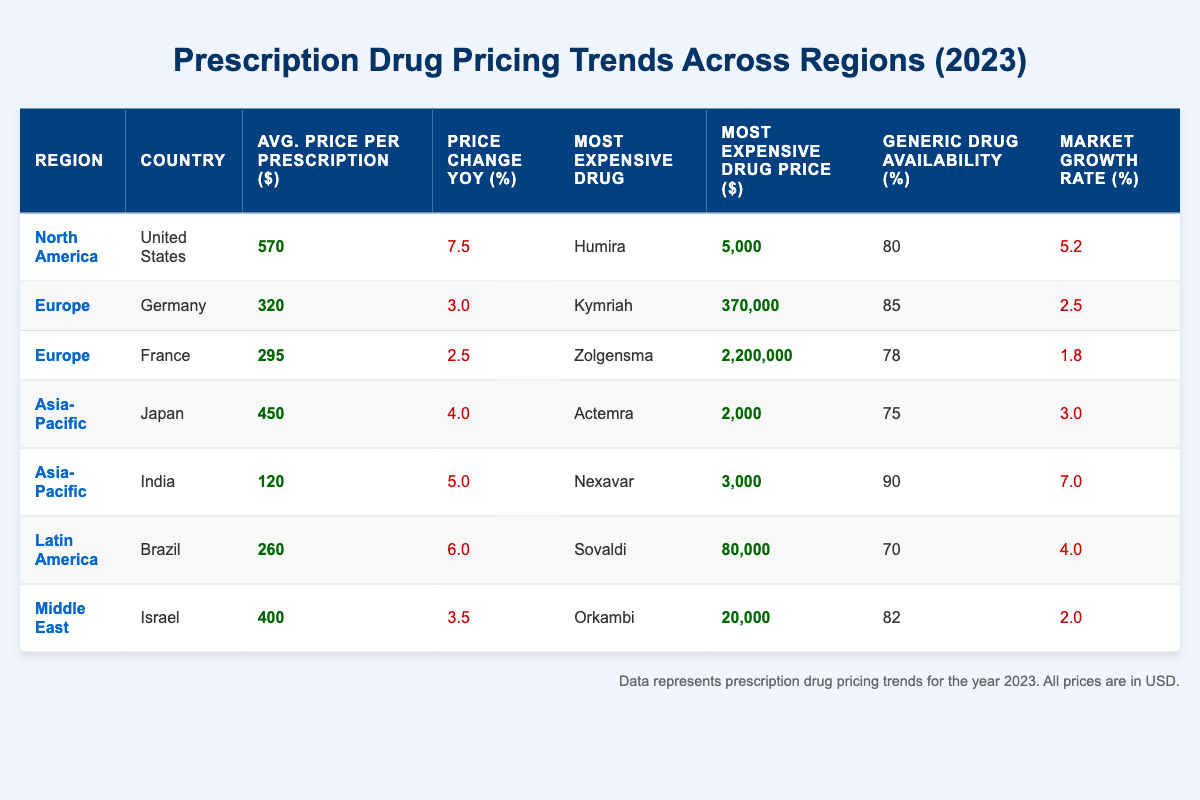What is the most expensive drug in the United States? The table indicates that the most expensive drug in the United States is Humira, which is listed in the row for North America.
Answer: Humira Which region has the highest average price per prescription? By examining the “Average Price Per Prescription” column, North America has an average price of 570, which is greater than all other regions listed.
Answer: North America What is the price change year over year for Germany? The table shows that Germany has a "Price Change Year Over Year" value of 3.0%.
Answer: 3.0% Is generic drug availability highest in India or Brazil? Comparing the "Generic Drug Availability" percentages, India has 90% and Brazil has 70%, so India has a higher availability.
Answer: India What is the average price per prescription for the Asia-Pacific region? To find the average, sum the values 450 (Japan) and 120 (India) and divide by 2: (450 + 120) / 2 = 285.
Answer: 285 Which country has the most expensive drug price in 2023? The most expensive drug price shown in the table is for France's Zolgensma at 2,200,000, which is greater than the other listed drug prices.
Answer: France What is the market growth rate in Israel? The table indicates that Israel has a market growth rate of 2.0%.
Answer: 2.0% Which country had a price change year over year of 6.0%? By looking in the "Price Change Year Over Year" column, Brazil is listed with a value of 6.0%.
Answer: Brazil If you combine the generic drug availability from Japan and India, what total percentage is that? Add the values together: 75 (Japan) + 90 (India) = 165%.
Answer: 165% Are the average prescription prices in Europe higher than in Latin America? North America's average price is 570, Europe's average prices are 320 (Germany) and 295 (France); Latin America's average price is 260 (Brazil). Upon comparison, all European averages are higher than Latin American.
Answer: Yes 